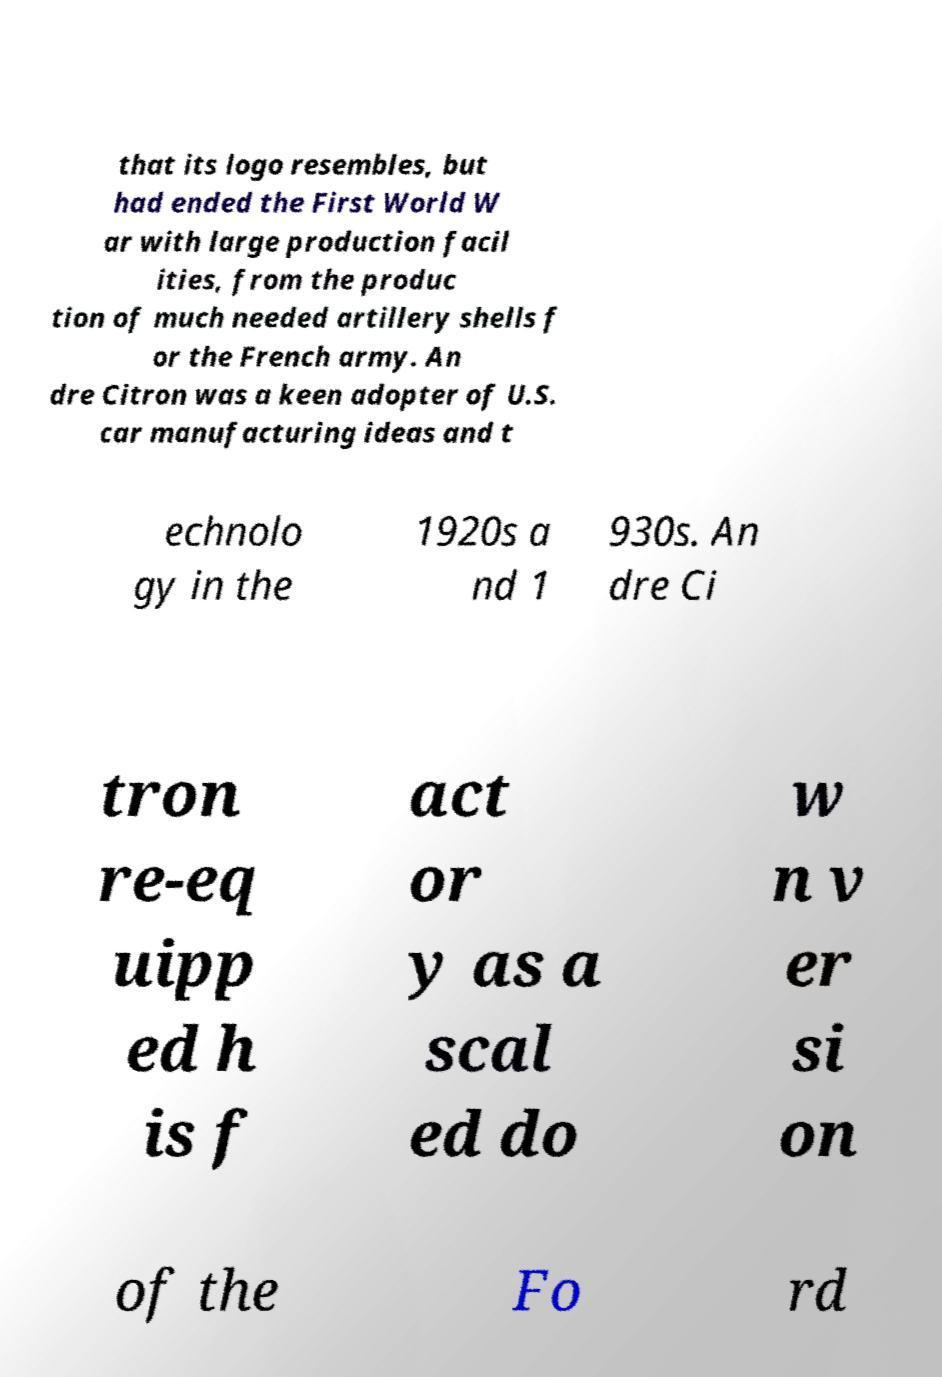I need the written content from this picture converted into text. Can you do that? that its logo resembles, but had ended the First World W ar with large production facil ities, from the produc tion of much needed artillery shells f or the French army. An dre Citron was a keen adopter of U.S. car manufacturing ideas and t echnolo gy in the 1920s a nd 1 930s. An dre Ci tron re-eq uipp ed h is f act or y as a scal ed do w n v er si on of the Fo rd 